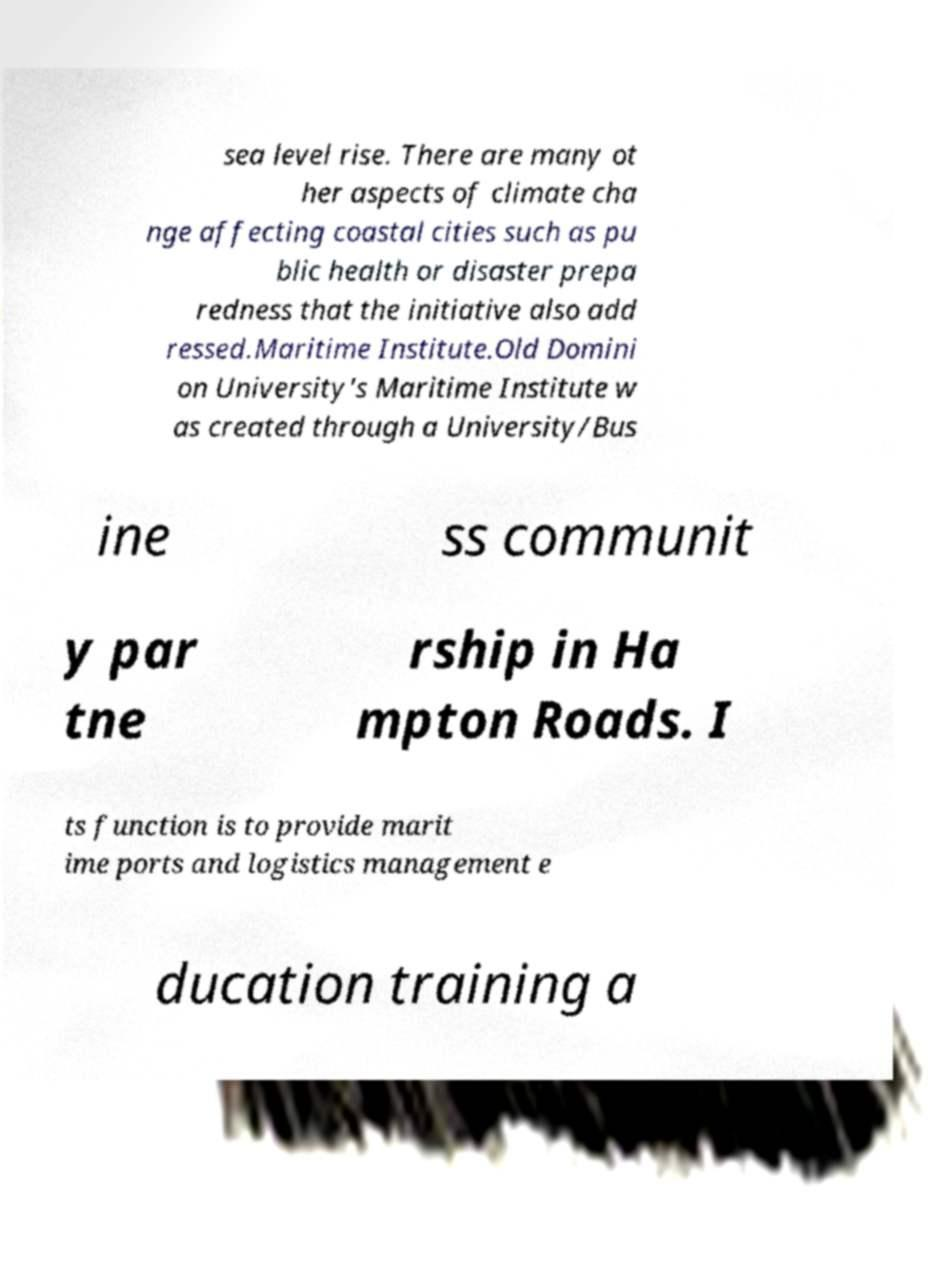Can you accurately transcribe the text from the provided image for me? sea level rise. There are many ot her aspects of climate cha nge affecting coastal cities such as pu blic health or disaster prepa redness that the initiative also add ressed.Maritime Institute.Old Domini on University's Maritime Institute w as created through a University/Bus ine ss communit y par tne rship in Ha mpton Roads. I ts function is to provide marit ime ports and logistics management e ducation training a 